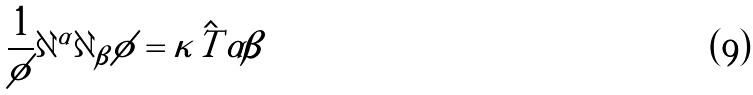Convert formula to latex. <formula><loc_0><loc_0><loc_500><loc_500>\frac { 1 } { \phi } \partial ^ { \alpha } \partial _ { \beta } \phi = \kappa \hat { T } { \alpha \beta }</formula> 